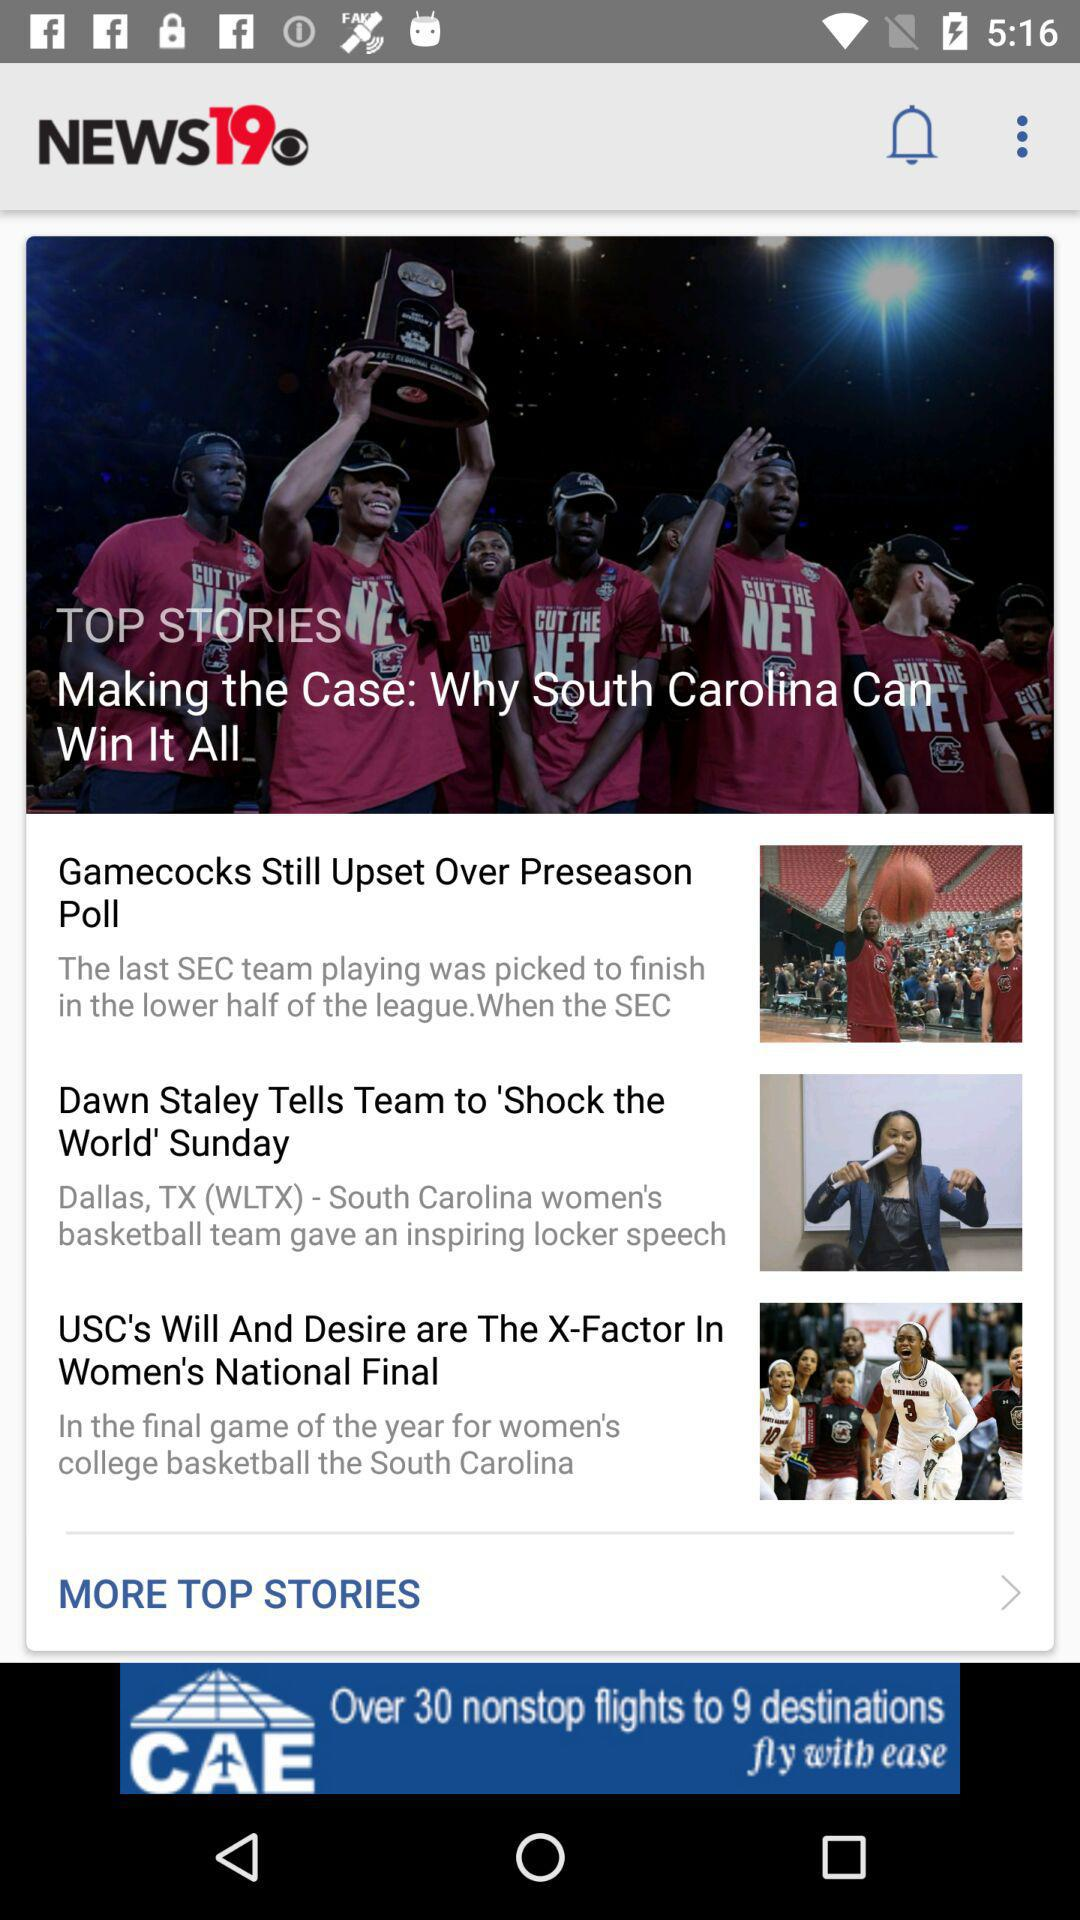How many more stories are there after the first story?
Answer the question using a single word or phrase. 2 